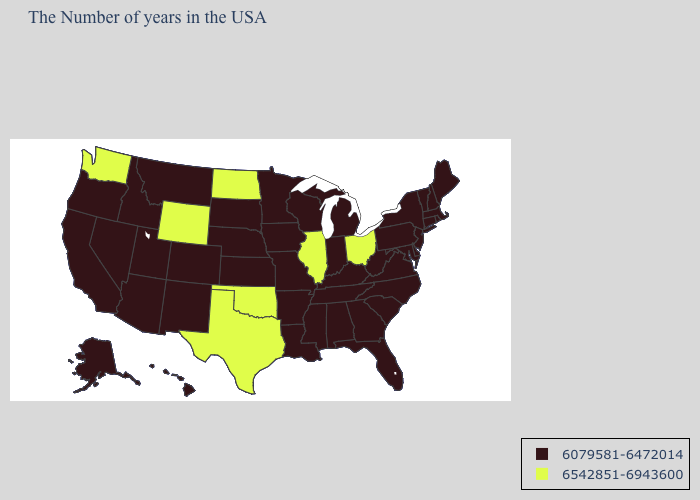How many symbols are there in the legend?
Give a very brief answer. 2. What is the highest value in states that border Tennessee?
Be succinct. 6079581-6472014. Which states have the lowest value in the MidWest?
Quick response, please. Michigan, Indiana, Wisconsin, Missouri, Minnesota, Iowa, Kansas, Nebraska, South Dakota. Does Alabama have the same value as California?
Be succinct. Yes. What is the lowest value in states that border Kansas?
Short answer required. 6079581-6472014. What is the lowest value in the South?
Give a very brief answer. 6079581-6472014. Does the first symbol in the legend represent the smallest category?
Give a very brief answer. Yes. Does North Dakota have the lowest value in the USA?
Keep it brief. No. Does Connecticut have a lower value than Illinois?
Quick response, please. Yes. Which states have the lowest value in the USA?
Answer briefly. Maine, Massachusetts, Rhode Island, New Hampshire, Vermont, Connecticut, New York, New Jersey, Delaware, Maryland, Pennsylvania, Virginia, North Carolina, South Carolina, West Virginia, Florida, Georgia, Michigan, Kentucky, Indiana, Alabama, Tennessee, Wisconsin, Mississippi, Louisiana, Missouri, Arkansas, Minnesota, Iowa, Kansas, Nebraska, South Dakota, Colorado, New Mexico, Utah, Montana, Arizona, Idaho, Nevada, California, Oregon, Alaska, Hawaii. Name the states that have a value in the range 6079581-6472014?
Write a very short answer. Maine, Massachusetts, Rhode Island, New Hampshire, Vermont, Connecticut, New York, New Jersey, Delaware, Maryland, Pennsylvania, Virginia, North Carolina, South Carolina, West Virginia, Florida, Georgia, Michigan, Kentucky, Indiana, Alabama, Tennessee, Wisconsin, Mississippi, Louisiana, Missouri, Arkansas, Minnesota, Iowa, Kansas, Nebraska, South Dakota, Colorado, New Mexico, Utah, Montana, Arizona, Idaho, Nevada, California, Oregon, Alaska, Hawaii. Name the states that have a value in the range 6542851-6943600?
Concise answer only. Ohio, Illinois, Oklahoma, Texas, North Dakota, Wyoming, Washington. 